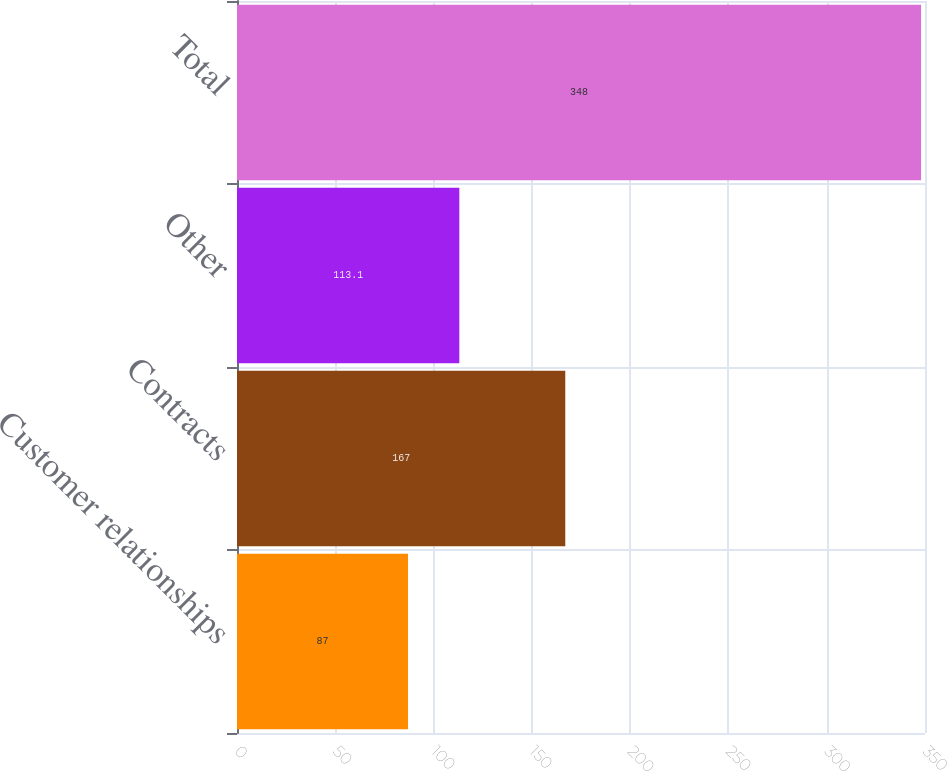<chart> <loc_0><loc_0><loc_500><loc_500><bar_chart><fcel>Customer relationships<fcel>Contracts<fcel>Other<fcel>Total<nl><fcel>87<fcel>167<fcel>113.1<fcel>348<nl></chart> 